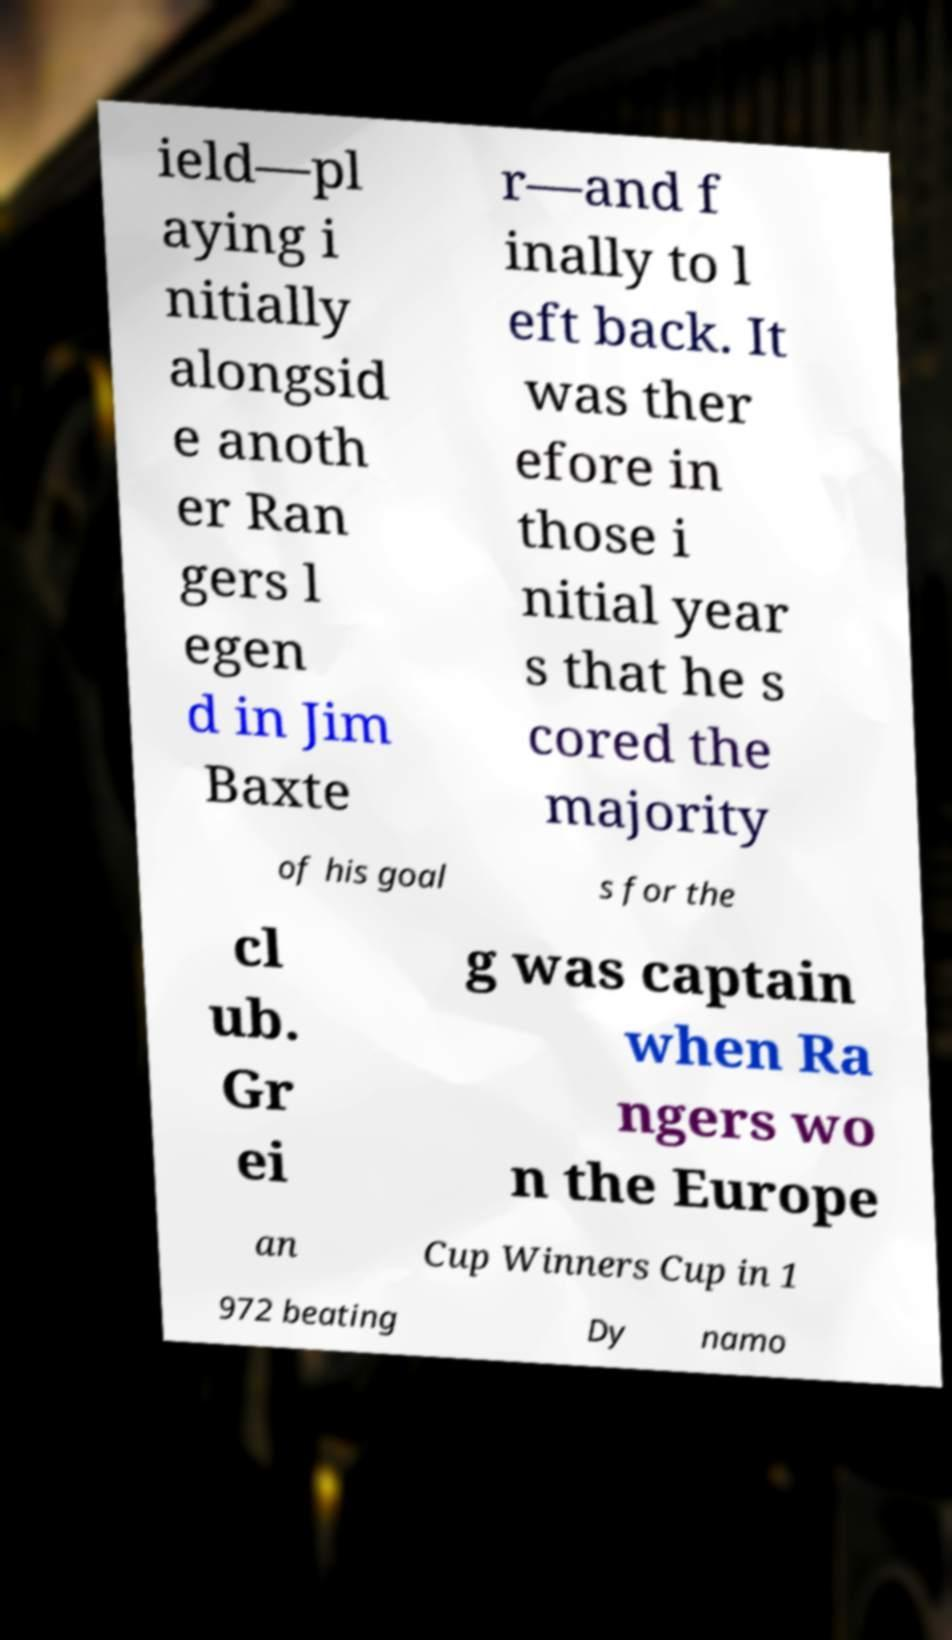Can you read and provide the text displayed in the image?This photo seems to have some interesting text. Can you extract and type it out for me? ield—pl aying i nitially alongsid e anoth er Ran gers l egen d in Jim Baxte r—and f inally to l eft back. It was ther efore in those i nitial year s that he s cored the majority of his goal s for the cl ub. Gr ei g was captain when Ra ngers wo n the Europe an Cup Winners Cup in 1 972 beating Dy namo 